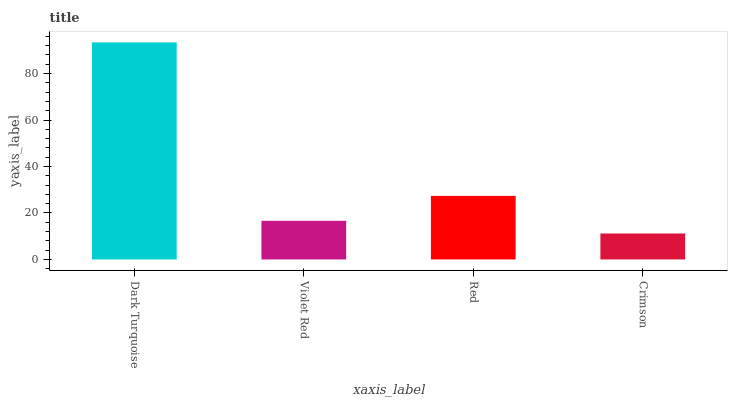Is Crimson the minimum?
Answer yes or no. Yes. Is Dark Turquoise the maximum?
Answer yes or no. Yes. Is Violet Red the minimum?
Answer yes or no. No. Is Violet Red the maximum?
Answer yes or no. No. Is Dark Turquoise greater than Violet Red?
Answer yes or no. Yes. Is Violet Red less than Dark Turquoise?
Answer yes or no. Yes. Is Violet Red greater than Dark Turquoise?
Answer yes or no. No. Is Dark Turquoise less than Violet Red?
Answer yes or no. No. Is Red the high median?
Answer yes or no. Yes. Is Violet Red the low median?
Answer yes or no. Yes. Is Dark Turquoise the high median?
Answer yes or no. No. Is Dark Turquoise the low median?
Answer yes or no. No. 